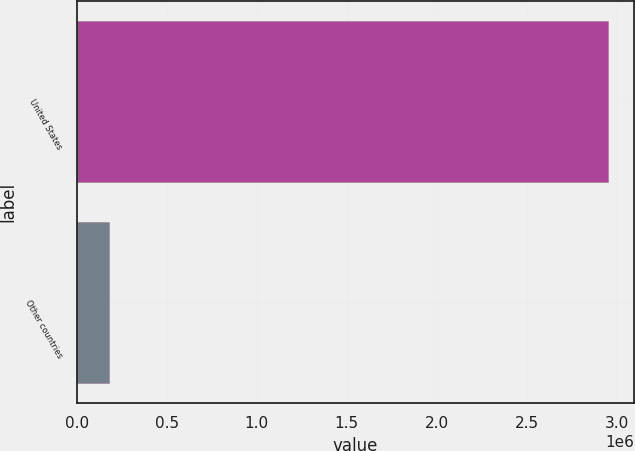Convert chart to OTSL. <chart><loc_0><loc_0><loc_500><loc_500><bar_chart><fcel>United States<fcel>Other countries<nl><fcel>2.95262e+06<fcel>178756<nl></chart> 